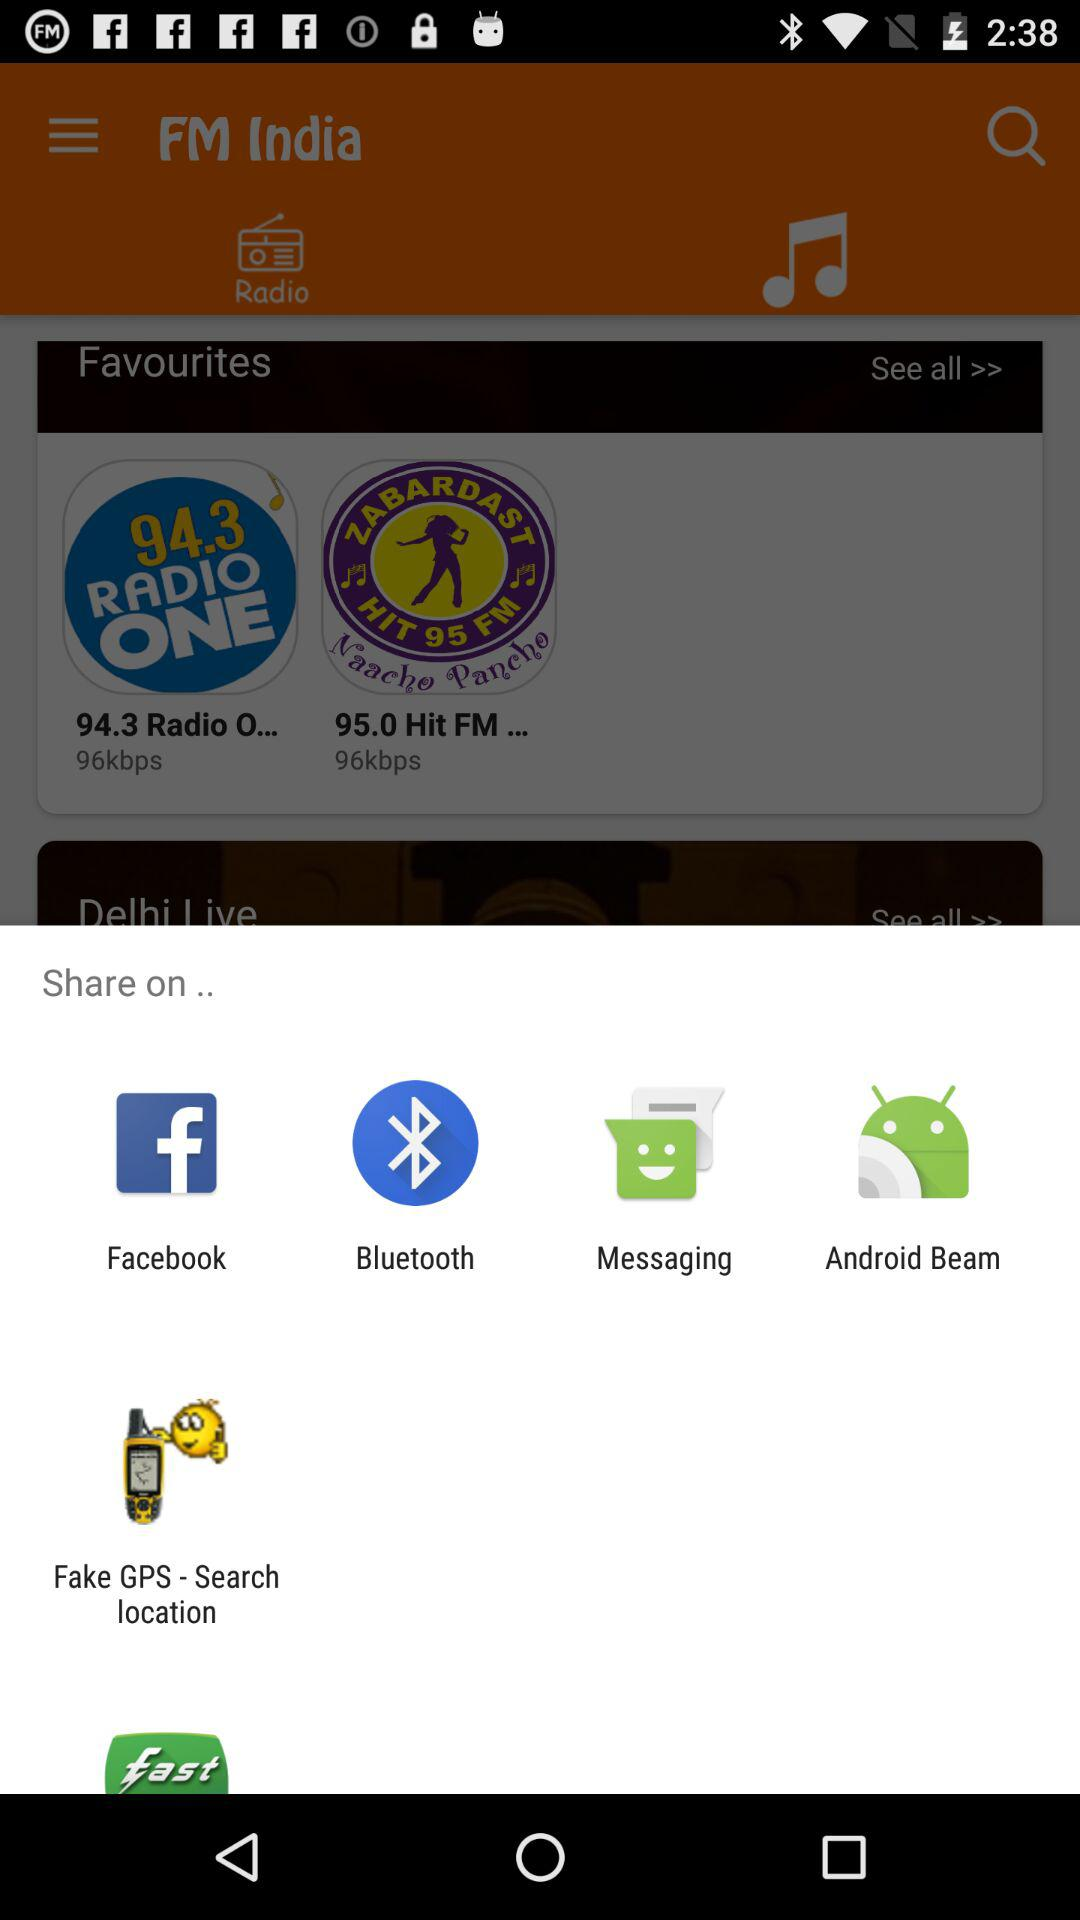Which show is now playing on "Delhi Live"?
When the provided information is insufficient, respond with <no answer>. <no answer> 